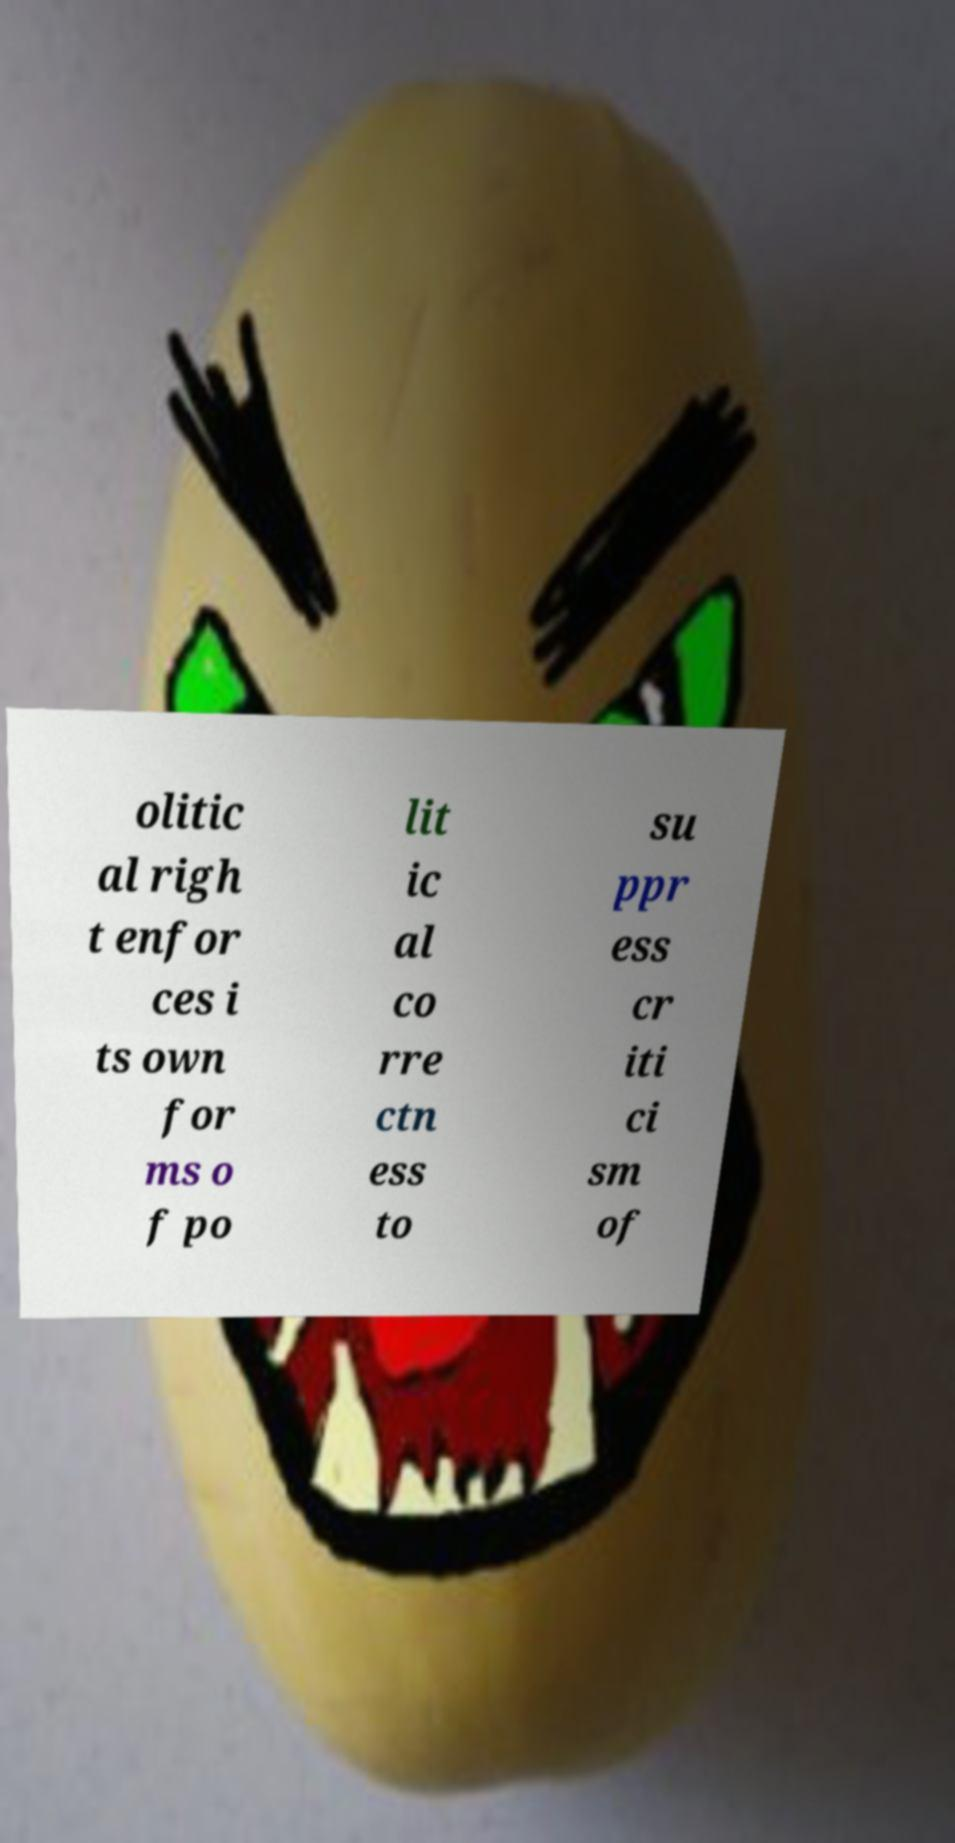Could you extract and type out the text from this image? olitic al righ t enfor ces i ts own for ms o f po lit ic al co rre ctn ess to su ppr ess cr iti ci sm of 